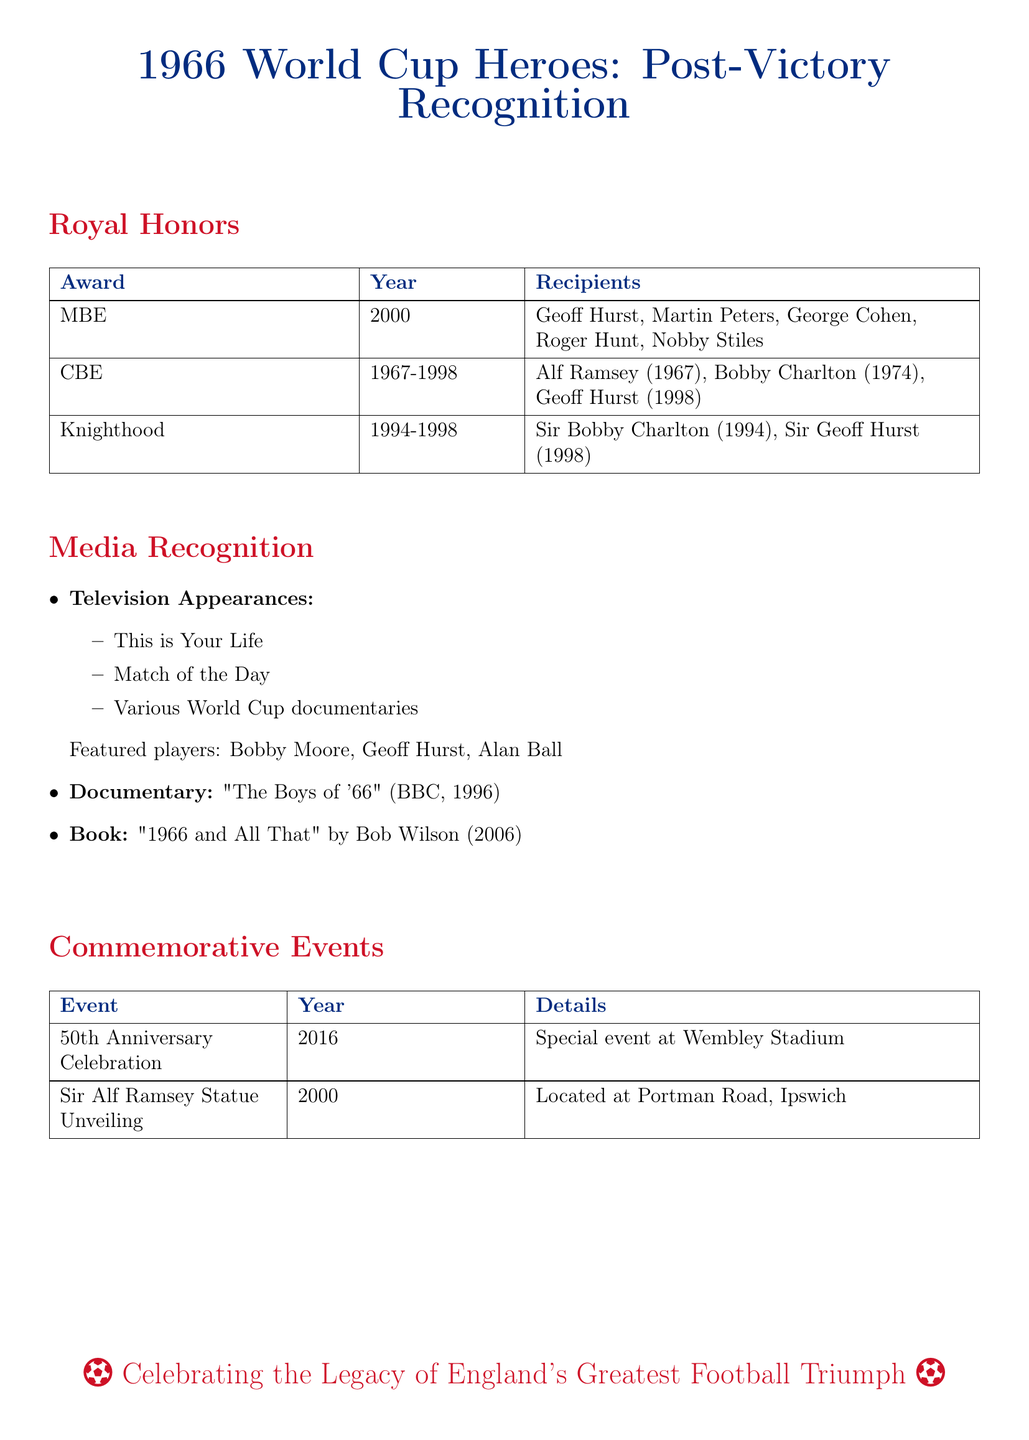What award was given to Geoff Hurst in 2000? The document states that Geoff Hurst received the MBE award in 2000.
Answer: MBE How many players received the MBE award in 2000? The document lists five players who received the MBE award in 2000.
Answer: Five What television show featured Bobby Moore, Geoff Hurst, and Alan Ball? The document mentions "This is Your Life" as a television show that featured these players.
Answer: This is Your Life In what year was the Sir Alf Ramsey statue unveiled? According to the document, the Sir Alf Ramsey statue was unveiled in 2000.
Answer: 2000 Which player received a knighthood in 1994? The document states that Sir Bobby Charlton received a knighthood in 1994.
Answer: Sir Bobby Charlton What commemorative event took place at Wembley Stadium in 2016? The document notes that the 50th Anniversary Celebration was held at Wembley Stadium in 2016.
Answer: 50th Anniversary Celebration What documentary was released by BBC in 1996? "The Boys of '66" is the documentary released by BBC in 1996 as mentioned in the document.
Answer: The Boys of '66 What honors were awarded to players from 1967 to 1998? The document lists the CBE as an honor awarded to players during this period.
Answer: CBE 